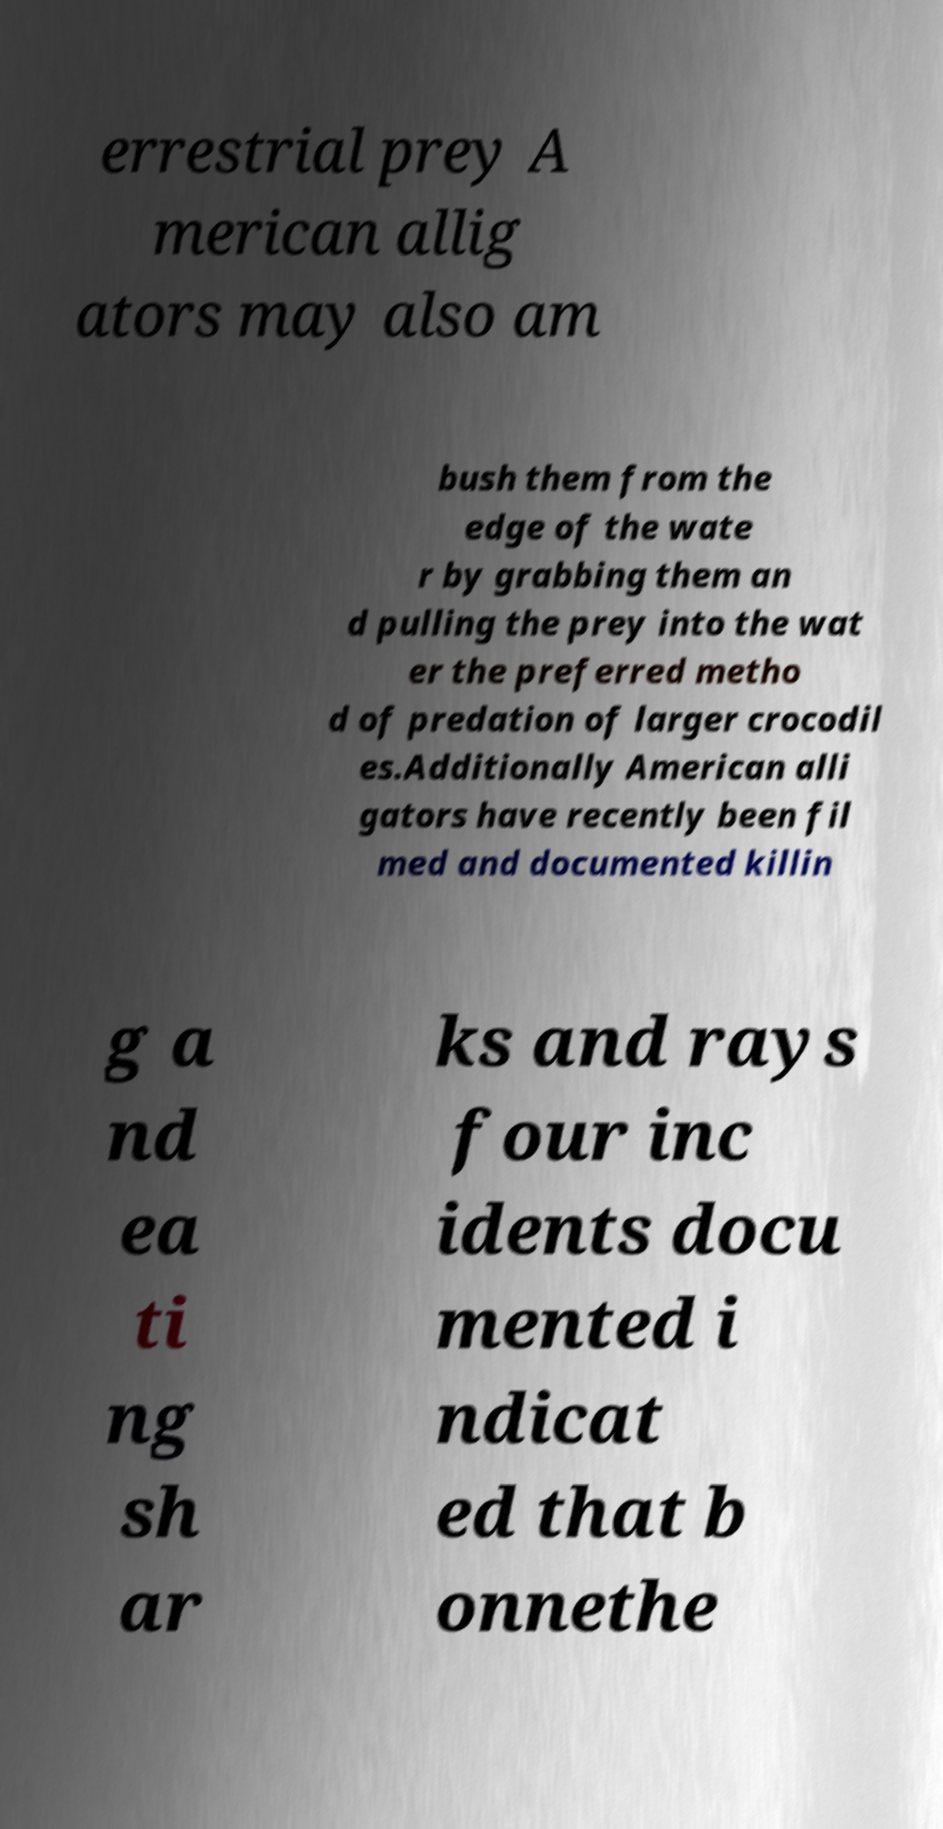Please identify and transcribe the text found in this image. errestrial prey A merican allig ators may also am bush them from the edge of the wate r by grabbing them an d pulling the prey into the wat er the preferred metho d of predation of larger crocodil es.Additionally American alli gators have recently been fil med and documented killin g a nd ea ti ng sh ar ks and rays four inc idents docu mented i ndicat ed that b onnethe 